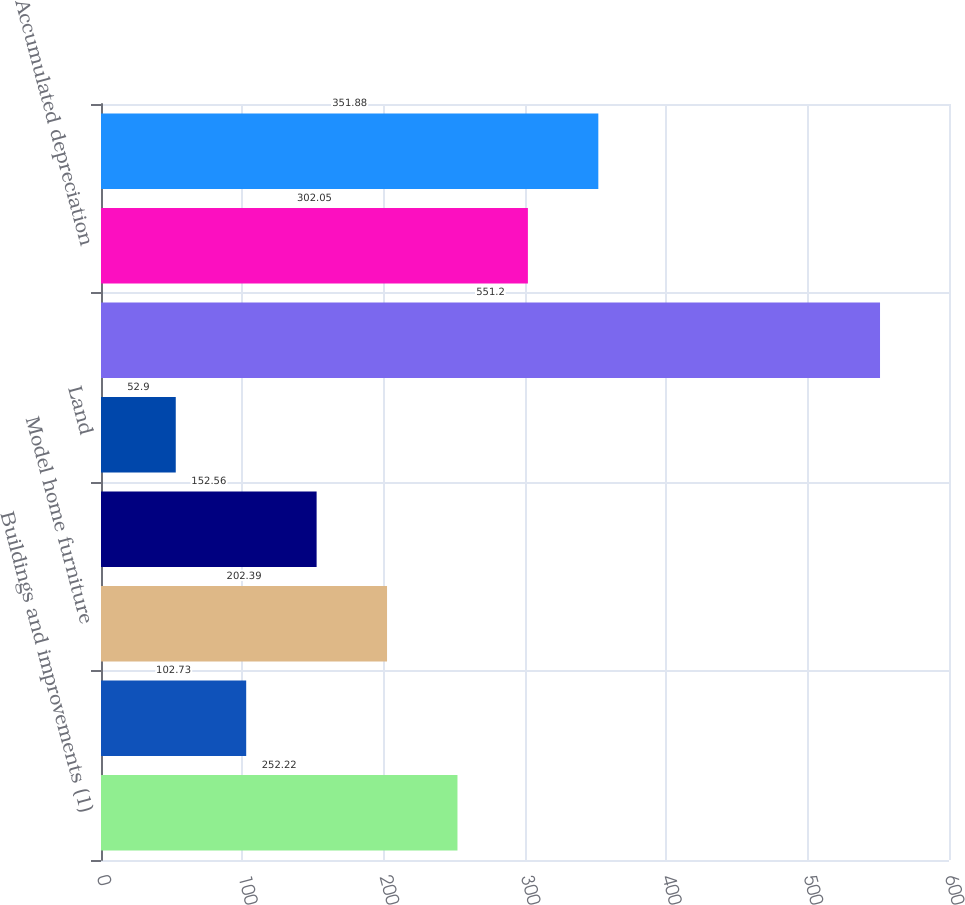Convert chart. <chart><loc_0><loc_0><loc_500><loc_500><bar_chart><fcel>Buildings and improvements (1)<fcel>Multi-family rental properties<fcel>Model home furniture<fcel>Office furniture and equipment<fcel>Land<fcel>Total property and equipment<fcel>Accumulated depreciation<fcel>Property and equipment net<nl><fcel>252.22<fcel>102.73<fcel>202.39<fcel>152.56<fcel>52.9<fcel>551.2<fcel>302.05<fcel>351.88<nl></chart> 